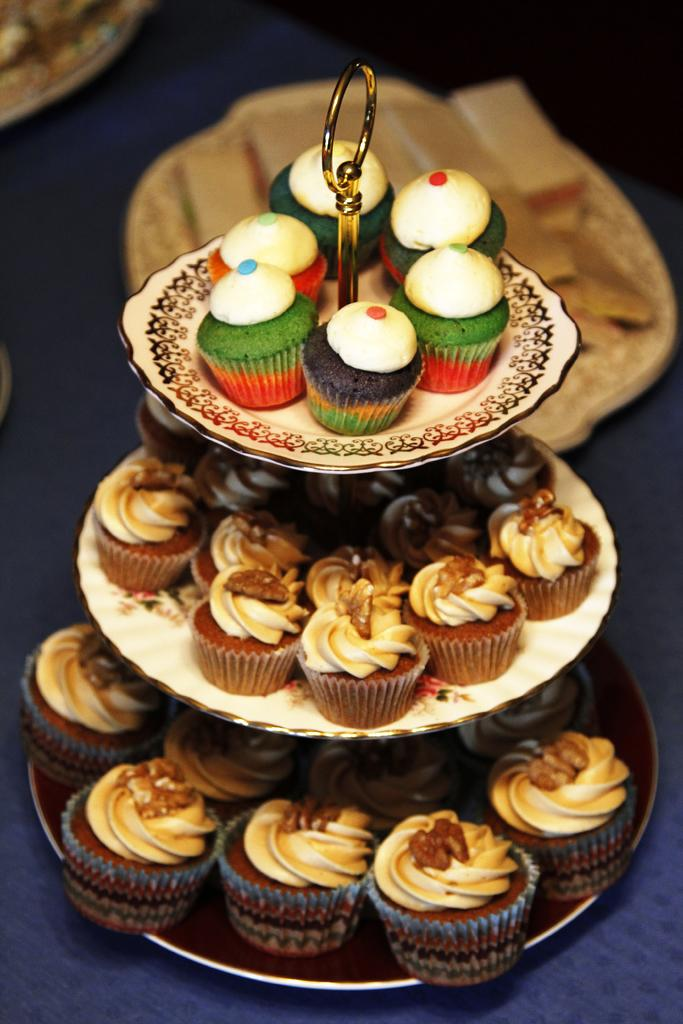What type of food can be seen in the image? There are muffins in the image. How are the muffins displayed in the image? The muffins are on a cake stand. Where is the cake stand located in the image? The cake stand is on a table. What type of flower is smashed on the table in the image? There is no flower present in the image, let alone a smashed one. 